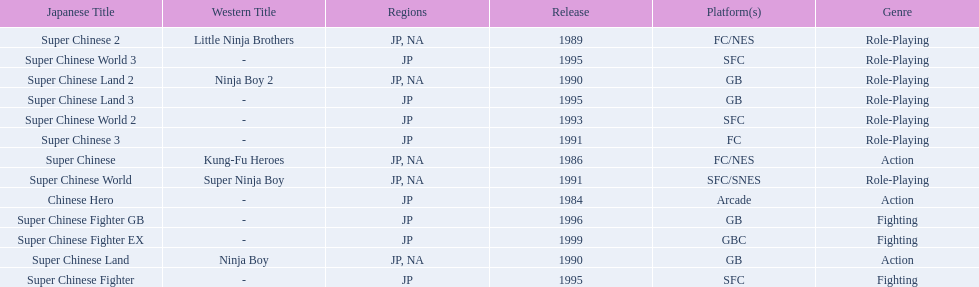Which titles were released in north america? Super Chinese, Super Chinese 2, Super Chinese Land, Super Chinese Land 2, Super Chinese World. Of those, which had the least releases? Super Chinese World. 